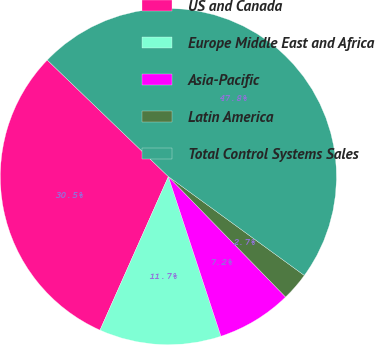<chart> <loc_0><loc_0><loc_500><loc_500><pie_chart><fcel>US and Canada<fcel>Europe Middle East and Africa<fcel>Asia-Pacific<fcel>Latin America<fcel>Total Control Systems Sales<nl><fcel>30.52%<fcel>11.73%<fcel>7.22%<fcel>2.71%<fcel>47.81%<nl></chart> 